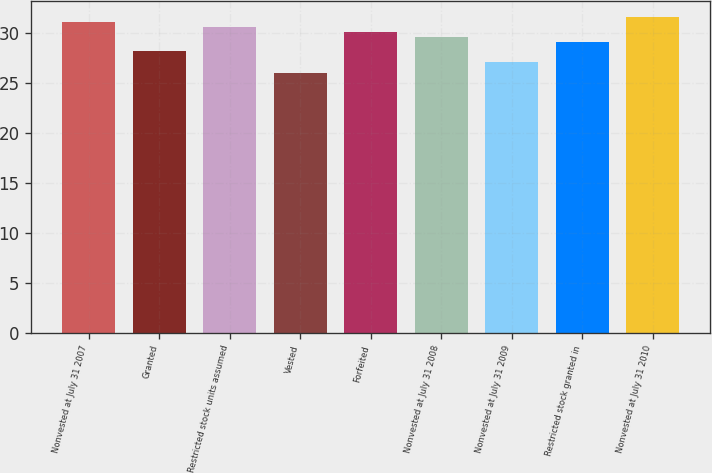Convert chart. <chart><loc_0><loc_0><loc_500><loc_500><bar_chart><fcel>Nonvested at July 31 2007<fcel>Granted<fcel>Restricted stock units assumed<fcel>Vested<fcel>Forfeited<fcel>Nonvested at July 31 2008<fcel>Nonvested at July 31 2009<fcel>Restricted stock granted in<fcel>Nonvested at July 31 2010<nl><fcel>31.14<fcel>28.24<fcel>30.64<fcel>25.96<fcel>30.14<fcel>29.64<fcel>27.06<fcel>29.14<fcel>31.64<nl></chart> 